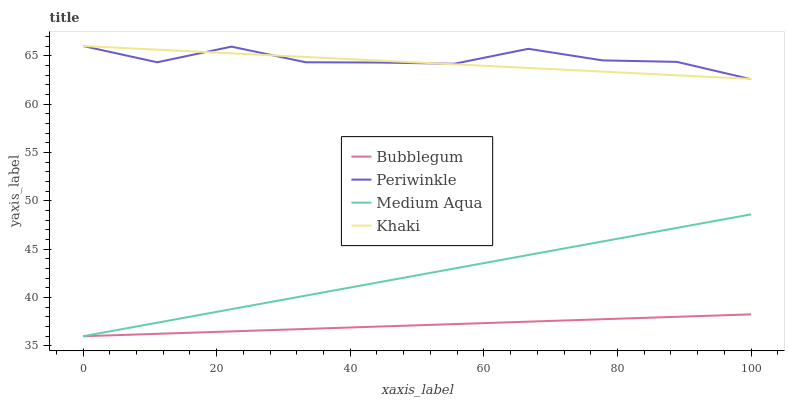Does Khaki have the minimum area under the curve?
Answer yes or no. No. Does Khaki have the maximum area under the curve?
Answer yes or no. No. Is Khaki the smoothest?
Answer yes or no. No. Is Khaki the roughest?
Answer yes or no. No. Does Periwinkle have the lowest value?
Answer yes or no. No. Does Bubblegum have the highest value?
Answer yes or no. No. Is Medium Aqua less than Periwinkle?
Answer yes or no. Yes. Is Periwinkle greater than Medium Aqua?
Answer yes or no. Yes. Does Medium Aqua intersect Periwinkle?
Answer yes or no. No. 